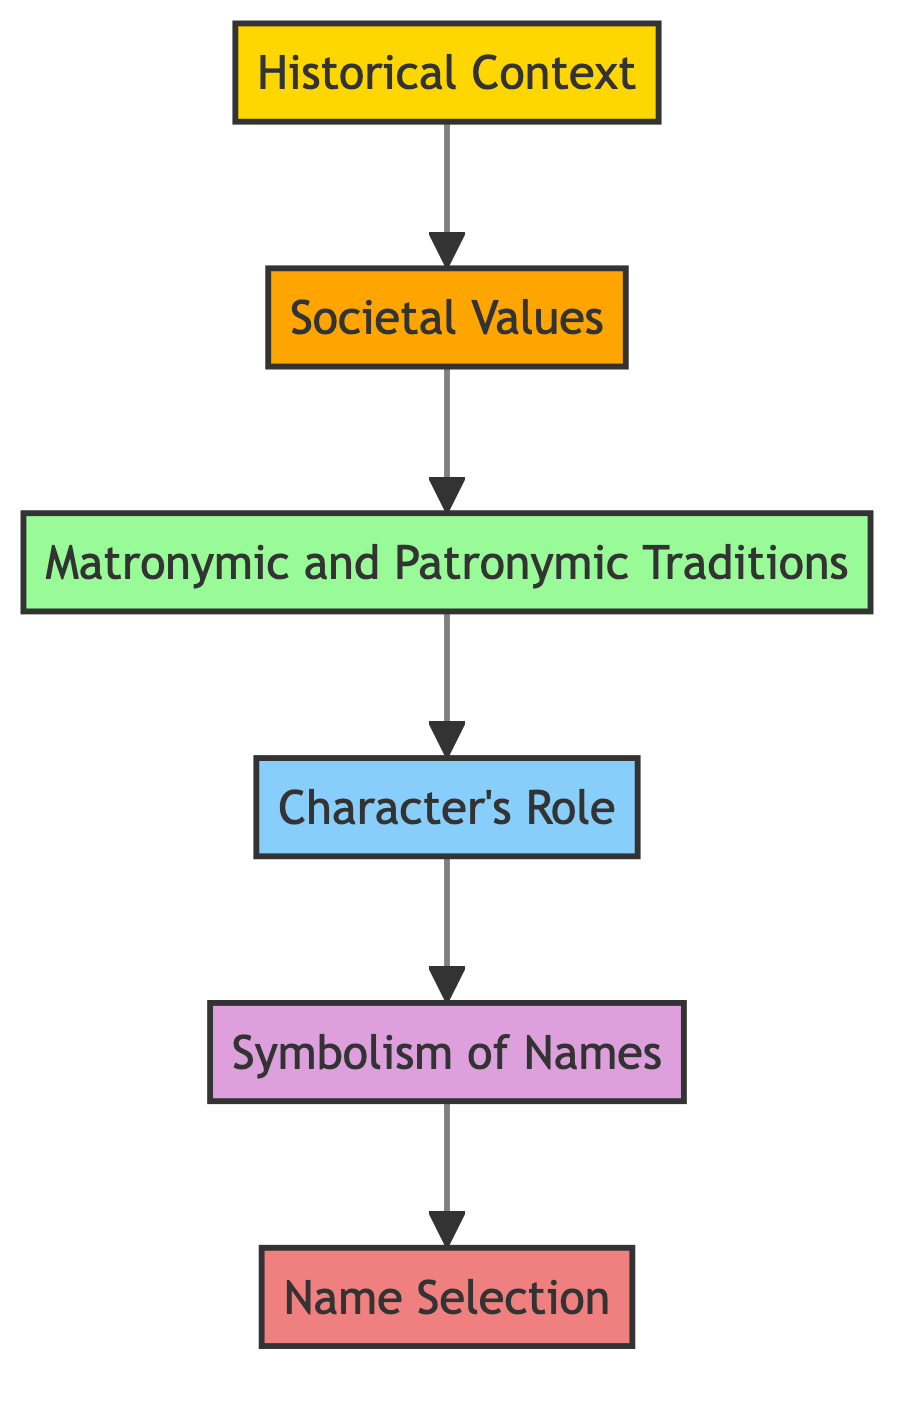What is the first node in the diagram? The first node is labeled "Historical Context," which is the starting point of the flow in the diagram.
Answer: Historical Context Which node directly follows "Historical Context"? The node that directly follows "Historical Context" is labeled "Societal Values," indicating the next step in the flow.
Answer: Societal Values How many total nodes are in the diagram? There are a total of six nodes present in the diagram, each representing a step in the naming process.
Answer: Six What is the relationship between "Character's Role" and "Symbolism of Names"? "Character's Role" flows into "Symbolism of Names," suggesting that the understanding of the character's role is a prerequisite to analyzing the symbolism of their names.
Answer: Flows into What is the last node in the flowchart? The last node in the flowchart is labeled "Name Selection," which indicates the final step in the process of selecting names for literary characters.
Answer: Name Selection How does "Matronymic and Patronymic Traditions" connect to "Character's Role"? "Matronymic and Patronymic Traditions" connects to "Character's Role" as they flow sequentially, indicating that understanding naming traditions informs the assessment of the character's role and characteristics.
Answer: Flows into What is the significance of the "Symbolism of Names" node in relation to the prior nodes? The "Symbolism of Names" node is significant as it follows "Character's Role" and highlights that the chosen names carry deeper meanings linked to the character's traits and actions, accumulated from prior nodes.
Answer: Deeper meanings linked to traits and actions Which node emphasizes the historical era of the literary work? The node that emphasizes the historical era of the literary work is "Historical Context," as it establishes the foundation for the subsequent analysis of names and their meanings.
Answer: Historical Context 